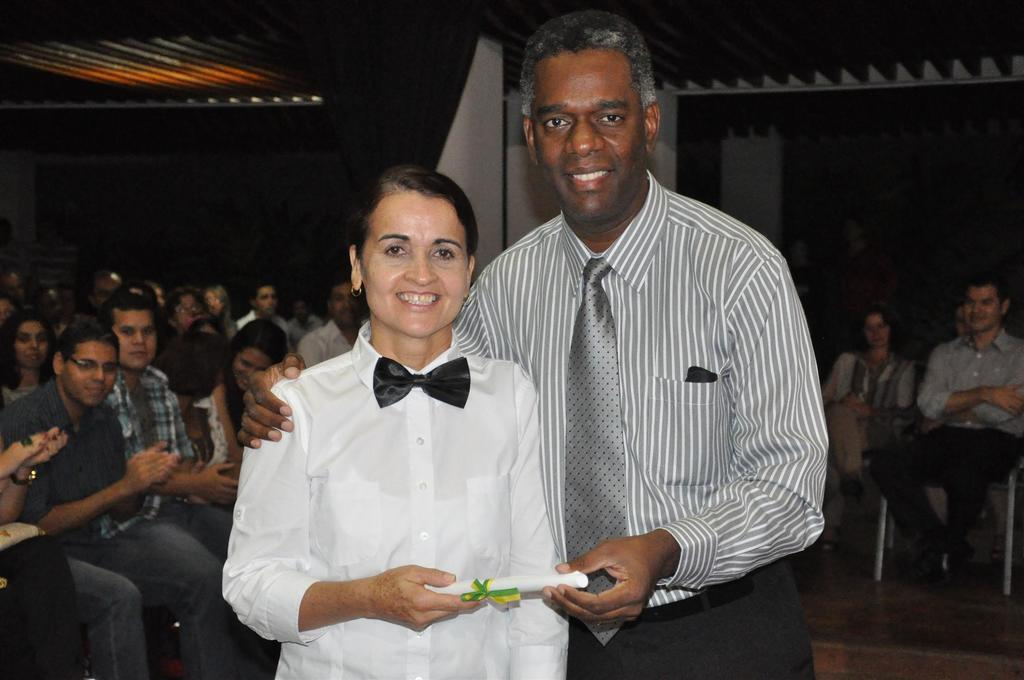How many people are present in the image? There are two people standing in the image. What are the two people holding? The two people are holding something. What can be seen in the background of the image? There is a group of people sitting on chairs in the background. What is the color of the background in the image? The background of the image is dark. How many babies are crawling on the cobweb in the image? There are no babies or cobwebs present in the image. Is the story depicted in the image a work of fiction or non-fiction? The image does not depict a story, so it cannot be classified as fiction or non-fiction. 